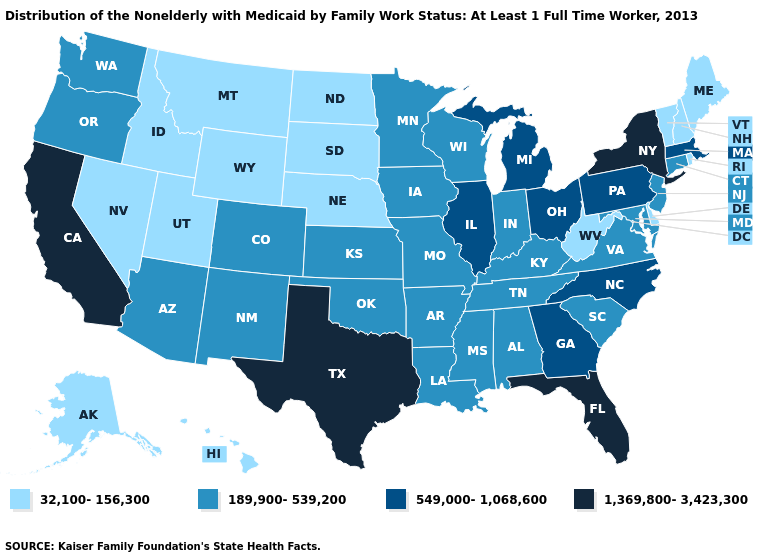What is the value of Missouri?
Write a very short answer. 189,900-539,200. What is the value of Oregon?
Give a very brief answer. 189,900-539,200. What is the highest value in states that border Maryland?
Short answer required. 549,000-1,068,600. Is the legend a continuous bar?
Keep it brief. No. Does Michigan have a lower value than Arizona?
Short answer required. No. Name the states that have a value in the range 549,000-1,068,600?
Answer briefly. Georgia, Illinois, Massachusetts, Michigan, North Carolina, Ohio, Pennsylvania. Name the states that have a value in the range 32,100-156,300?
Concise answer only. Alaska, Delaware, Hawaii, Idaho, Maine, Montana, Nebraska, Nevada, New Hampshire, North Dakota, Rhode Island, South Dakota, Utah, Vermont, West Virginia, Wyoming. What is the highest value in states that border Iowa?
Short answer required. 549,000-1,068,600. What is the highest value in the USA?
Concise answer only. 1,369,800-3,423,300. Does Florida have the highest value in the USA?
Short answer required. Yes. Name the states that have a value in the range 1,369,800-3,423,300?
Quick response, please. California, Florida, New York, Texas. What is the lowest value in the MidWest?
Quick response, please. 32,100-156,300. Among the states that border Florida , which have the lowest value?
Keep it brief. Alabama. What is the highest value in states that border Maine?
Keep it brief. 32,100-156,300. Is the legend a continuous bar?
Give a very brief answer. No. 